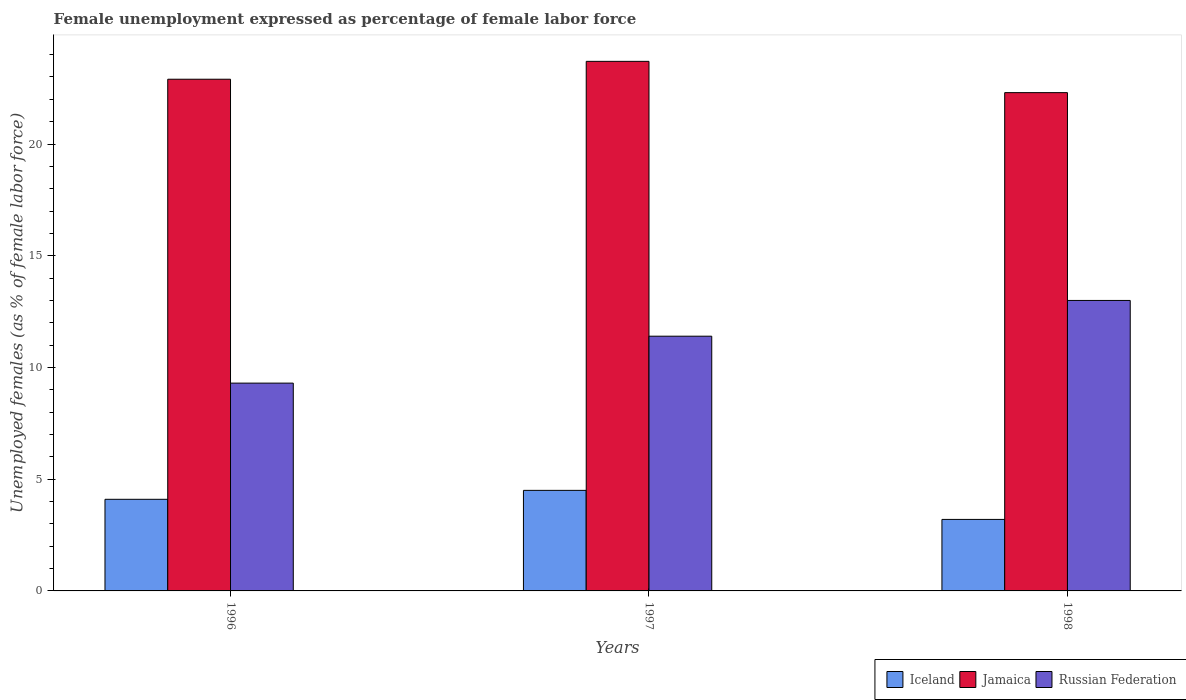How many groups of bars are there?
Your answer should be compact. 3. Are the number of bars per tick equal to the number of legend labels?
Your response must be concise. Yes. Are the number of bars on each tick of the X-axis equal?
Your answer should be compact. Yes. How many bars are there on the 3rd tick from the left?
Keep it short and to the point. 3. How many bars are there on the 3rd tick from the right?
Your response must be concise. 3. What is the label of the 2nd group of bars from the left?
Give a very brief answer. 1997. In how many cases, is the number of bars for a given year not equal to the number of legend labels?
Keep it short and to the point. 0. What is the unemployment in females in in Jamaica in 1998?
Ensure brevity in your answer.  22.3. Across all years, what is the minimum unemployment in females in in Jamaica?
Your answer should be very brief. 22.3. In which year was the unemployment in females in in Jamaica maximum?
Your answer should be very brief. 1997. In which year was the unemployment in females in in Russian Federation minimum?
Offer a very short reply. 1996. What is the total unemployment in females in in Iceland in the graph?
Keep it short and to the point. 11.8. What is the difference between the unemployment in females in in Russian Federation in 1997 and that in 1998?
Provide a short and direct response. -1.6. What is the difference between the unemployment in females in in Iceland in 1997 and the unemployment in females in in Russian Federation in 1996?
Give a very brief answer. -4.8. What is the average unemployment in females in in Russian Federation per year?
Offer a terse response. 11.23. In the year 1997, what is the difference between the unemployment in females in in Iceland and unemployment in females in in Jamaica?
Ensure brevity in your answer.  -19.2. In how many years, is the unemployment in females in in Iceland greater than 14 %?
Offer a terse response. 0. What is the ratio of the unemployment in females in in Iceland in 1996 to that in 1997?
Provide a succinct answer. 0.91. Is the unemployment in females in in Iceland in 1996 less than that in 1998?
Keep it short and to the point. No. Is the difference between the unemployment in females in in Iceland in 1997 and 1998 greater than the difference between the unemployment in females in in Jamaica in 1997 and 1998?
Provide a succinct answer. No. What is the difference between the highest and the second highest unemployment in females in in Iceland?
Your response must be concise. 0.4. What is the difference between the highest and the lowest unemployment in females in in Iceland?
Your answer should be very brief. 1.3. In how many years, is the unemployment in females in in Jamaica greater than the average unemployment in females in in Jamaica taken over all years?
Your response must be concise. 1. Is the sum of the unemployment in females in in Iceland in 1996 and 1998 greater than the maximum unemployment in females in in Russian Federation across all years?
Your answer should be very brief. No. What does the 2nd bar from the right in 1997 represents?
Keep it short and to the point. Jamaica. How many bars are there?
Offer a very short reply. 9. What is the difference between two consecutive major ticks on the Y-axis?
Ensure brevity in your answer.  5. Are the values on the major ticks of Y-axis written in scientific E-notation?
Provide a short and direct response. No. Does the graph contain grids?
Your response must be concise. No. How many legend labels are there?
Give a very brief answer. 3. How are the legend labels stacked?
Offer a very short reply. Horizontal. What is the title of the graph?
Provide a short and direct response. Female unemployment expressed as percentage of female labor force. What is the label or title of the X-axis?
Make the answer very short. Years. What is the label or title of the Y-axis?
Provide a short and direct response. Unemployed females (as % of female labor force). What is the Unemployed females (as % of female labor force) of Iceland in 1996?
Provide a succinct answer. 4.1. What is the Unemployed females (as % of female labor force) of Jamaica in 1996?
Keep it short and to the point. 22.9. What is the Unemployed females (as % of female labor force) in Russian Federation in 1996?
Give a very brief answer. 9.3. What is the Unemployed females (as % of female labor force) of Iceland in 1997?
Provide a short and direct response. 4.5. What is the Unemployed females (as % of female labor force) in Jamaica in 1997?
Offer a terse response. 23.7. What is the Unemployed females (as % of female labor force) in Russian Federation in 1997?
Ensure brevity in your answer.  11.4. What is the Unemployed females (as % of female labor force) in Iceland in 1998?
Provide a succinct answer. 3.2. What is the Unemployed females (as % of female labor force) of Jamaica in 1998?
Ensure brevity in your answer.  22.3. What is the Unemployed females (as % of female labor force) of Russian Federation in 1998?
Keep it short and to the point. 13. Across all years, what is the maximum Unemployed females (as % of female labor force) in Iceland?
Offer a terse response. 4.5. Across all years, what is the maximum Unemployed females (as % of female labor force) in Jamaica?
Provide a succinct answer. 23.7. Across all years, what is the maximum Unemployed females (as % of female labor force) in Russian Federation?
Your response must be concise. 13. Across all years, what is the minimum Unemployed females (as % of female labor force) of Iceland?
Ensure brevity in your answer.  3.2. Across all years, what is the minimum Unemployed females (as % of female labor force) of Jamaica?
Your response must be concise. 22.3. Across all years, what is the minimum Unemployed females (as % of female labor force) of Russian Federation?
Offer a terse response. 9.3. What is the total Unemployed females (as % of female labor force) in Jamaica in the graph?
Make the answer very short. 68.9. What is the total Unemployed females (as % of female labor force) of Russian Federation in the graph?
Your answer should be compact. 33.7. What is the difference between the Unemployed females (as % of female labor force) in Iceland in 1996 and that in 1997?
Your response must be concise. -0.4. What is the difference between the Unemployed females (as % of female labor force) of Jamaica in 1996 and that in 1997?
Make the answer very short. -0.8. What is the difference between the Unemployed females (as % of female labor force) in Iceland in 1996 and that in 1998?
Offer a terse response. 0.9. What is the difference between the Unemployed females (as % of female labor force) in Jamaica in 1996 and that in 1998?
Your response must be concise. 0.6. What is the difference between the Unemployed females (as % of female labor force) in Russian Federation in 1996 and that in 1998?
Offer a terse response. -3.7. What is the difference between the Unemployed females (as % of female labor force) of Iceland in 1997 and that in 1998?
Provide a succinct answer. 1.3. What is the difference between the Unemployed females (as % of female labor force) of Jamaica in 1997 and that in 1998?
Keep it short and to the point. 1.4. What is the difference between the Unemployed females (as % of female labor force) in Russian Federation in 1997 and that in 1998?
Provide a succinct answer. -1.6. What is the difference between the Unemployed females (as % of female labor force) of Iceland in 1996 and the Unemployed females (as % of female labor force) of Jamaica in 1997?
Your answer should be very brief. -19.6. What is the difference between the Unemployed females (as % of female labor force) in Iceland in 1996 and the Unemployed females (as % of female labor force) in Russian Federation in 1997?
Keep it short and to the point. -7.3. What is the difference between the Unemployed females (as % of female labor force) in Iceland in 1996 and the Unemployed females (as % of female labor force) in Jamaica in 1998?
Your answer should be very brief. -18.2. What is the difference between the Unemployed females (as % of female labor force) in Iceland in 1996 and the Unemployed females (as % of female labor force) in Russian Federation in 1998?
Your response must be concise. -8.9. What is the difference between the Unemployed females (as % of female labor force) in Iceland in 1997 and the Unemployed females (as % of female labor force) in Jamaica in 1998?
Give a very brief answer. -17.8. What is the difference between the Unemployed females (as % of female labor force) of Iceland in 1997 and the Unemployed females (as % of female labor force) of Russian Federation in 1998?
Your response must be concise. -8.5. What is the average Unemployed females (as % of female labor force) in Iceland per year?
Give a very brief answer. 3.93. What is the average Unemployed females (as % of female labor force) of Jamaica per year?
Provide a succinct answer. 22.97. What is the average Unemployed females (as % of female labor force) of Russian Federation per year?
Keep it short and to the point. 11.23. In the year 1996, what is the difference between the Unemployed females (as % of female labor force) in Iceland and Unemployed females (as % of female labor force) in Jamaica?
Offer a terse response. -18.8. In the year 1996, what is the difference between the Unemployed females (as % of female labor force) of Iceland and Unemployed females (as % of female labor force) of Russian Federation?
Your answer should be very brief. -5.2. In the year 1997, what is the difference between the Unemployed females (as % of female labor force) in Iceland and Unemployed females (as % of female labor force) in Jamaica?
Make the answer very short. -19.2. In the year 1997, what is the difference between the Unemployed females (as % of female labor force) of Iceland and Unemployed females (as % of female labor force) of Russian Federation?
Keep it short and to the point. -6.9. In the year 1997, what is the difference between the Unemployed females (as % of female labor force) in Jamaica and Unemployed females (as % of female labor force) in Russian Federation?
Give a very brief answer. 12.3. In the year 1998, what is the difference between the Unemployed females (as % of female labor force) in Iceland and Unemployed females (as % of female labor force) in Jamaica?
Your answer should be very brief. -19.1. In the year 1998, what is the difference between the Unemployed females (as % of female labor force) of Iceland and Unemployed females (as % of female labor force) of Russian Federation?
Make the answer very short. -9.8. In the year 1998, what is the difference between the Unemployed females (as % of female labor force) of Jamaica and Unemployed females (as % of female labor force) of Russian Federation?
Provide a succinct answer. 9.3. What is the ratio of the Unemployed females (as % of female labor force) of Iceland in 1996 to that in 1997?
Provide a short and direct response. 0.91. What is the ratio of the Unemployed females (as % of female labor force) of Jamaica in 1996 to that in 1997?
Your response must be concise. 0.97. What is the ratio of the Unemployed females (as % of female labor force) of Russian Federation in 1996 to that in 1997?
Ensure brevity in your answer.  0.82. What is the ratio of the Unemployed females (as % of female labor force) of Iceland in 1996 to that in 1998?
Your answer should be very brief. 1.28. What is the ratio of the Unemployed females (as % of female labor force) in Jamaica in 1996 to that in 1998?
Make the answer very short. 1.03. What is the ratio of the Unemployed females (as % of female labor force) in Russian Federation in 1996 to that in 1998?
Make the answer very short. 0.72. What is the ratio of the Unemployed females (as % of female labor force) of Iceland in 1997 to that in 1998?
Your response must be concise. 1.41. What is the ratio of the Unemployed females (as % of female labor force) of Jamaica in 1997 to that in 1998?
Offer a very short reply. 1.06. What is the ratio of the Unemployed females (as % of female labor force) in Russian Federation in 1997 to that in 1998?
Make the answer very short. 0.88. What is the difference between the highest and the second highest Unemployed females (as % of female labor force) of Iceland?
Offer a very short reply. 0.4. What is the difference between the highest and the second highest Unemployed females (as % of female labor force) of Russian Federation?
Provide a short and direct response. 1.6. What is the difference between the highest and the lowest Unemployed females (as % of female labor force) in Russian Federation?
Ensure brevity in your answer.  3.7. 